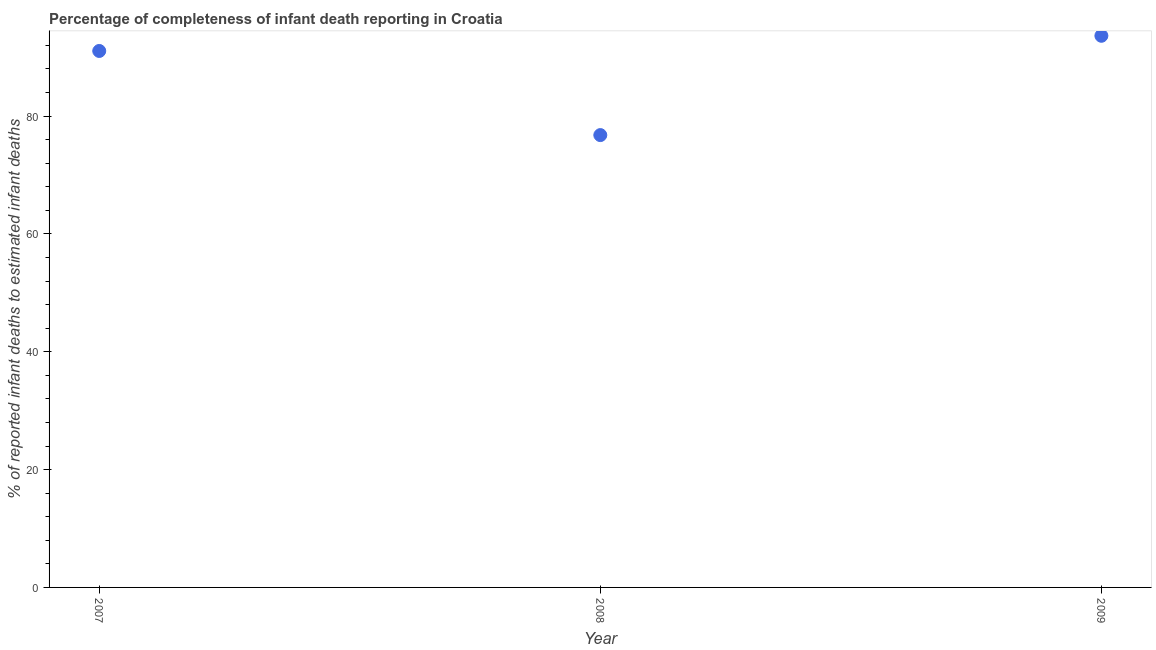What is the completeness of infant death reporting in 2009?
Ensure brevity in your answer.  93.63. Across all years, what is the maximum completeness of infant death reporting?
Keep it short and to the point. 93.63. Across all years, what is the minimum completeness of infant death reporting?
Your response must be concise. 76.77. In which year was the completeness of infant death reporting maximum?
Keep it short and to the point. 2009. In which year was the completeness of infant death reporting minimum?
Provide a short and direct response. 2008. What is the sum of the completeness of infant death reporting?
Your response must be concise. 261.45. What is the difference between the completeness of infant death reporting in 2008 and 2009?
Your response must be concise. -16.85. What is the average completeness of infant death reporting per year?
Offer a terse response. 87.15. What is the median completeness of infant death reporting?
Keep it short and to the point. 91.05. What is the ratio of the completeness of infant death reporting in 2007 to that in 2009?
Provide a succinct answer. 0.97. Is the completeness of infant death reporting in 2007 less than that in 2009?
Make the answer very short. Yes. What is the difference between the highest and the second highest completeness of infant death reporting?
Your answer should be very brief. 2.57. Is the sum of the completeness of infant death reporting in 2007 and 2008 greater than the maximum completeness of infant death reporting across all years?
Give a very brief answer. Yes. What is the difference between the highest and the lowest completeness of infant death reporting?
Provide a succinct answer. 16.85. In how many years, is the completeness of infant death reporting greater than the average completeness of infant death reporting taken over all years?
Provide a succinct answer. 2. Does the completeness of infant death reporting monotonically increase over the years?
Provide a succinct answer. No. Are the values on the major ticks of Y-axis written in scientific E-notation?
Your answer should be very brief. No. What is the title of the graph?
Your response must be concise. Percentage of completeness of infant death reporting in Croatia. What is the label or title of the X-axis?
Provide a short and direct response. Year. What is the label or title of the Y-axis?
Provide a short and direct response. % of reported infant deaths to estimated infant deaths. What is the % of reported infant deaths to estimated infant deaths in 2007?
Your answer should be compact. 91.05. What is the % of reported infant deaths to estimated infant deaths in 2008?
Provide a short and direct response. 76.77. What is the % of reported infant deaths to estimated infant deaths in 2009?
Keep it short and to the point. 93.63. What is the difference between the % of reported infant deaths to estimated infant deaths in 2007 and 2008?
Make the answer very short. 14.28. What is the difference between the % of reported infant deaths to estimated infant deaths in 2007 and 2009?
Your response must be concise. -2.57. What is the difference between the % of reported infant deaths to estimated infant deaths in 2008 and 2009?
Offer a terse response. -16.85. What is the ratio of the % of reported infant deaths to estimated infant deaths in 2007 to that in 2008?
Provide a succinct answer. 1.19. What is the ratio of the % of reported infant deaths to estimated infant deaths in 2007 to that in 2009?
Give a very brief answer. 0.97. What is the ratio of the % of reported infant deaths to estimated infant deaths in 2008 to that in 2009?
Make the answer very short. 0.82. 